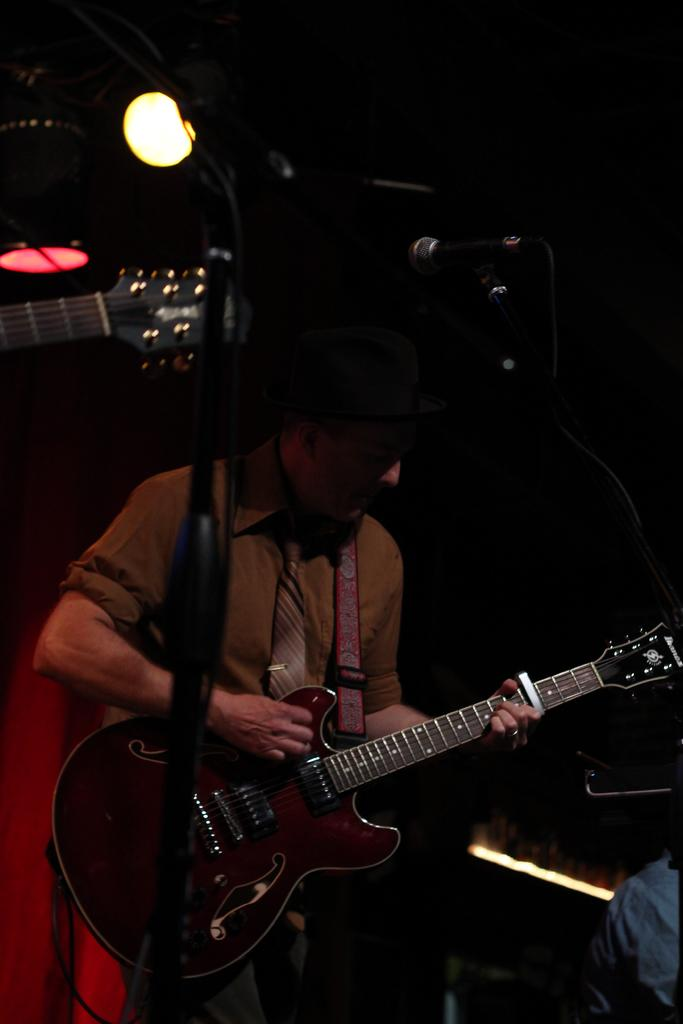What is the main subject of the image? There is a man in the image. What is the man holding in the image? The man is holding a guitar. Can you describe the man's clothing in the image? The man is wearing a black cap. What type of process is the man performing with the guitar in the image? There is no indication in the image of a specific process being performed with the guitar. 